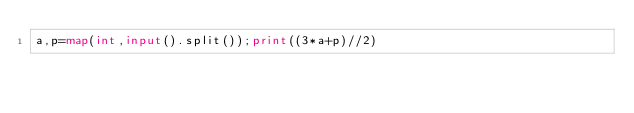Convert code to text. <code><loc_0><loc_0><loc_500><loc_500><_Python_>a,p=map(int,input().split());print((3*a+p)//2)</code> 